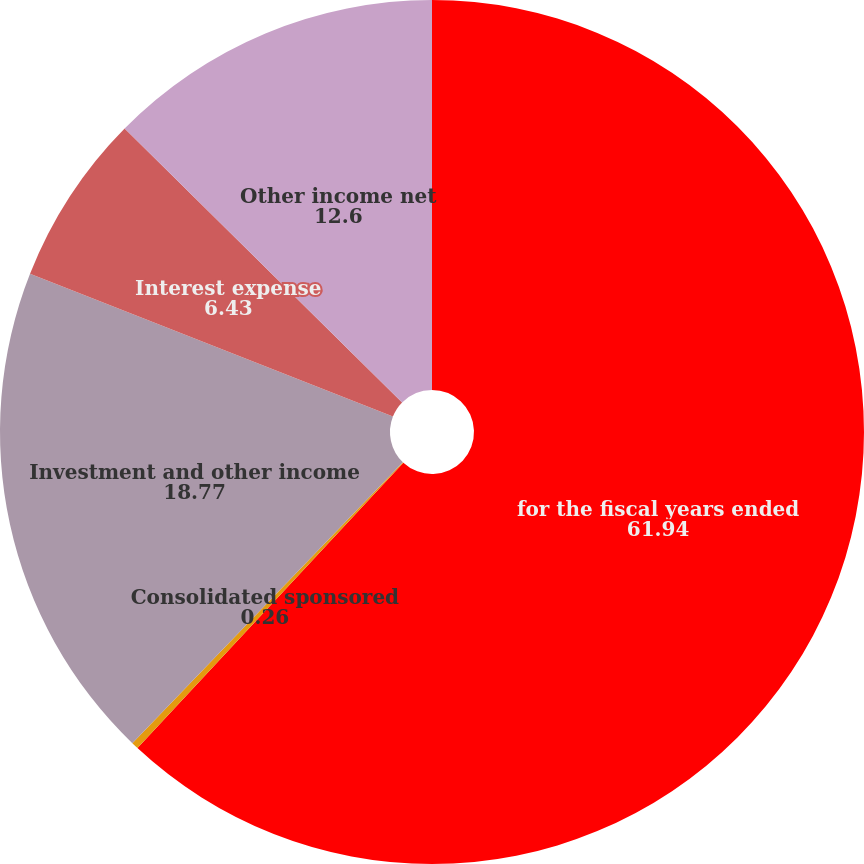Convert chart to OTSL. <chart><loc_0><loc_0><loc_500><loc_500><pie_chart><fcel>for the fiscal years ended<fcel>Consolidated sponsored<fcel>Investment and other income<fcel>Interest expense<fcel>Other income net<nl><fcel>61.94%<fcel>0.26%<fcel>18.77%<fcel>6.43%<fcel>12.6%<nl></chart> 